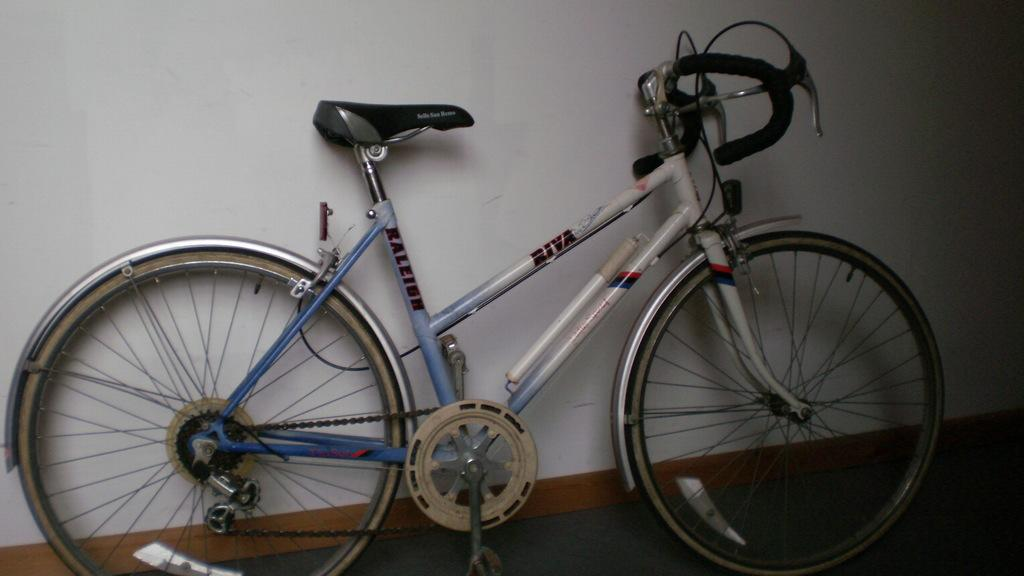What is the main object in the image? There is a bicycle in the image. Where is the bicycle located? The bicycle is in a room. What can be seen behind the bicycle? There is a white wall in the background of the image. What surface is the bicycle resting on? There is a floor visible in the image. What type of peace symbol can be seen on the bicycle in the image? There is no peace symbol present on the bicycle in the image. 